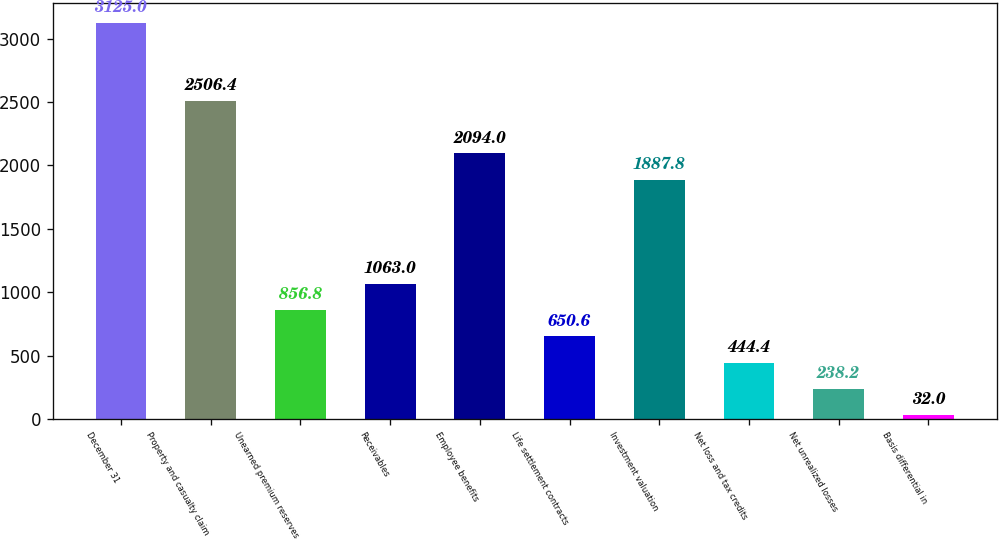Convert chart. <chart><loc_0><loc_0><loc_500><loc_500><bar_chart><fcel>December 31<fcel>Property and casualty claim<fcel>Unearned premium reserves<fcel>Receivables<fcel>Employee benefits<fcel>Life settlement contracts<fcel>Investment valuation<fcel>Net loss and tax credits<fcel>Net unrealized losses<fcel>Basis differential in<nl><fcel>3125<fcel>2506.4<fcel>856.8<fcel>1063<fcel>2094<fcel>650.6<fcel>1887.8<fcel>444.4<fcel>238.2<fcel>32<nl></chart> 